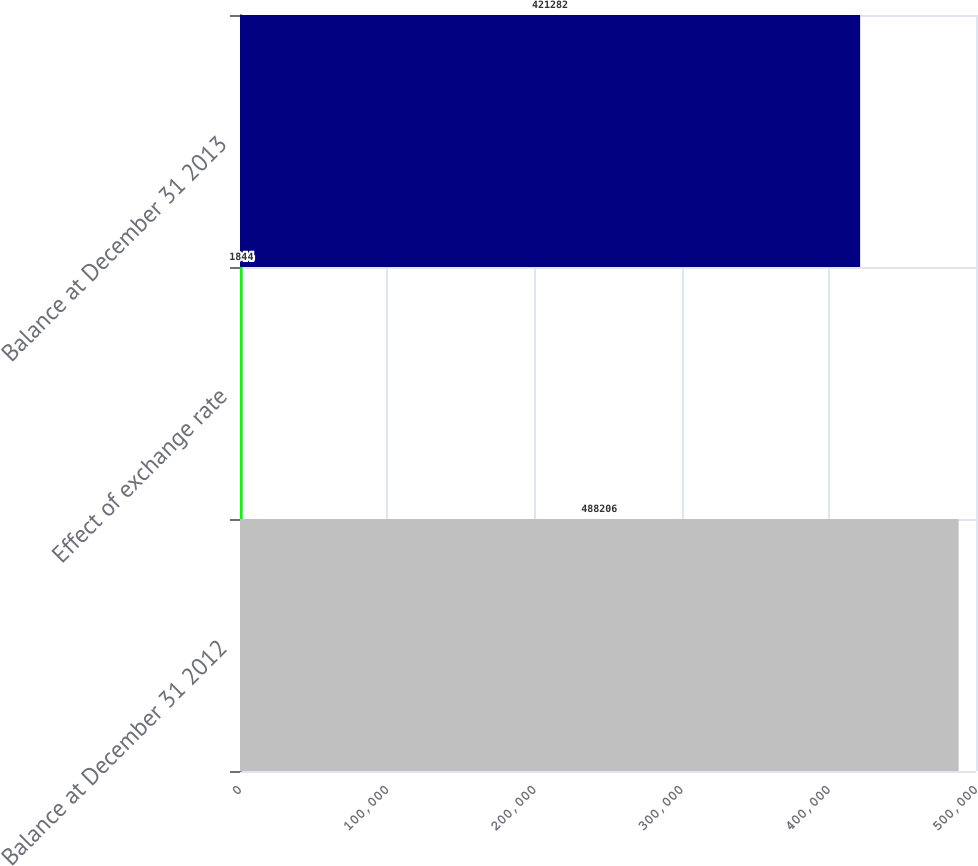Convert chart. <chart><loc_0><loc_0><loc_500><loc_500><bar_chart><fcel>Balance at December 31 2012<fcel>Effect of exchange rate<fcel>Balance at December 31 2013<nl><fcel>488206<fcel>1844<fcel>421282<nl></chart> 